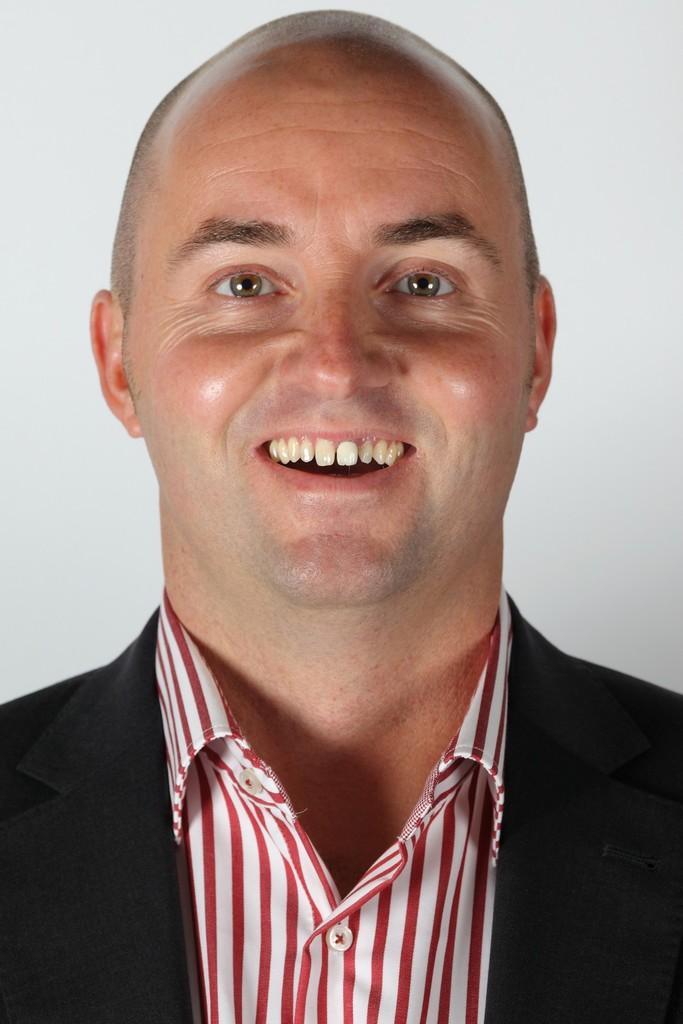Please provide a concise description of this image. In this image we can see a person wearing a black color blazer and the background is in white color. 